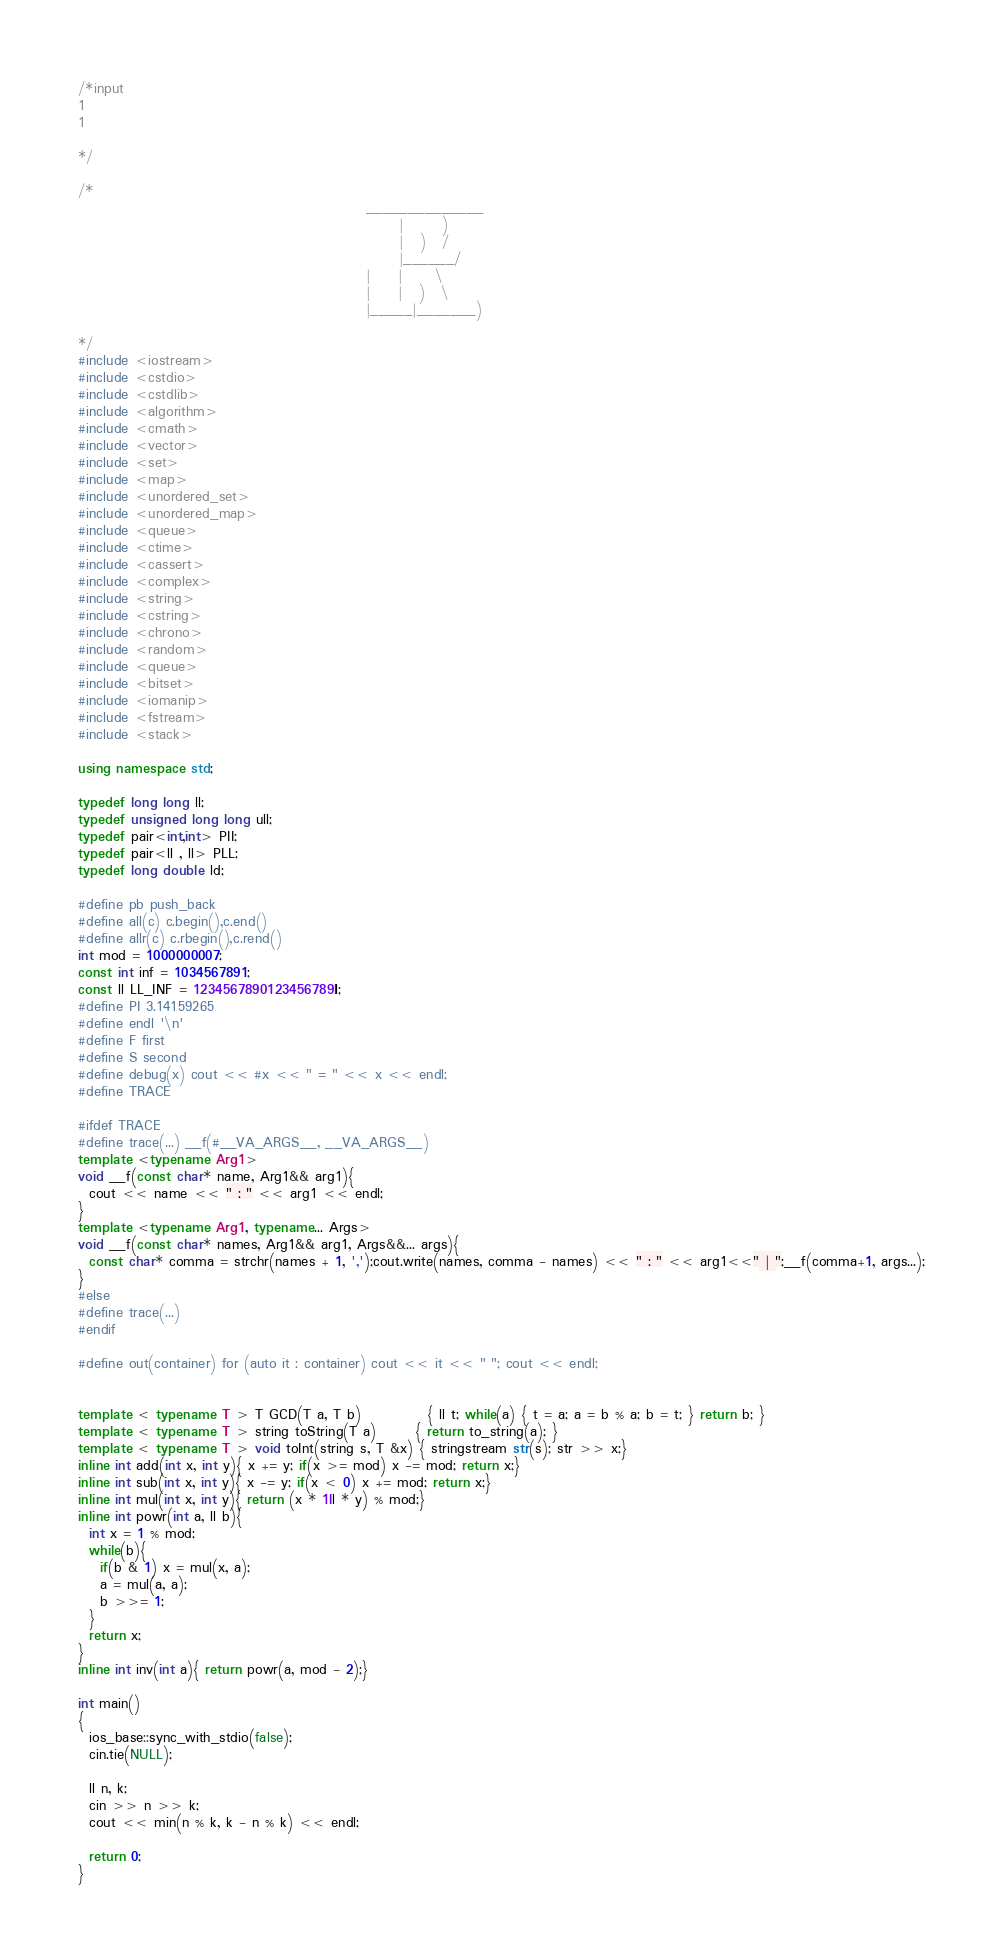Convert code to text. <code><loc_0><loc_0><loc_500><loc_500><_C++_>/*input
1
1

*/
 
/*
                                                    ______________
                                                          |       )
                                                          |   )   /
                                                          |______/
                                                    |     |      \
                                                    |     |   )   \
                                                    |_____|_______)
 
*/
#include <iostream>
#include <cstdio>
#include <cstdlib>
#include <algorithm>
#include <cmath>
#include <vector>
#include <set>
#include <map>
#include <unordered_set>
#include <unordered_map>
#include <queue>
#include <ctime>
#include <cassert>
#include <complex>
#include <string>
#include <cstring>
#include <chrono>
#include <random>
#include <queue>
#include <bitset>
#include <iomanip>
#include <fstream>
#include <stack>

using namespace std;
 
typedef long long ll;
typedef unsigned long long ull;
typedef pair<int,int> PII;
typedef pair<ll , ll> PLL;
typedef long double ld;
 
#define pb push_back
#define all(c) c.begin(),c.end()
#define allr(c) c.rbegin(),c.rend()
int mod = 1000000007;
const int inf = 1034567891;
const ll LL_INF = 1234567890123456789ll;
#define PI 3.14159265
#define endl '\n'
#define F first
#define S second
#define debug(x) cout << #x << " = " << x << endl;
#define TRACE
 
#ifdef TRACE
#define trace(...) __f(#__VA_ARGS__, __VA_ARGS__)
template <typename Arg1>
void __f(const char* name, Arg1&& arg1){
  cout << name << " : " << arg1 << endl;
}
template <typename Arg1, typename... Args>
void __f(const char* names, Arg1&& arg1, Args&&... args){
  const char* comma = strchr(names + 1, ',');cout.write(names, comma - names) << " : " << arg1<<" | ";__f(comma+1, args...);
}
#else
#define trace(...)
#endif
 
#define out(container) for (auto it : container) cout << it << " "; cout << endl;
 
 
template < typename T > T GCD(T a, T b)            { ll t; while(a) { t = a; a = b % a; b = t; } return b; }
template < typename T > string toString(T a)       { return to_string(a); }
template < typename T > void toInt(string s, T &x) { stringstream str(s); str >> x;}
inline int add(int x, int y){ x += y; if(x >= mod) x -= mod; return x;}
inline int sub(int x, int y){ x -= y; if(x < 0) x += mod; return x;}
inline int mul(int x, int y){ return (x * 1ll * y) % mod;}
inline int powr(int a, ll b){
  int x = 1 % mod;
  while(b){
    if(b & 1) x = mul(x, a);
    a = mul(a, a);
    b >>= 1;
  }
  return x;
}
inline int inv(int a){ return powr(a, mod - 2);}

int main()
{
  ios_base::sync_with_stdio(false);
  cin.tie(NULL);
  
  ll n, k;
  cin >> n >> k;
  cout << min(n % k, k - n % k) << endl;  

  return 0;
}</code> 